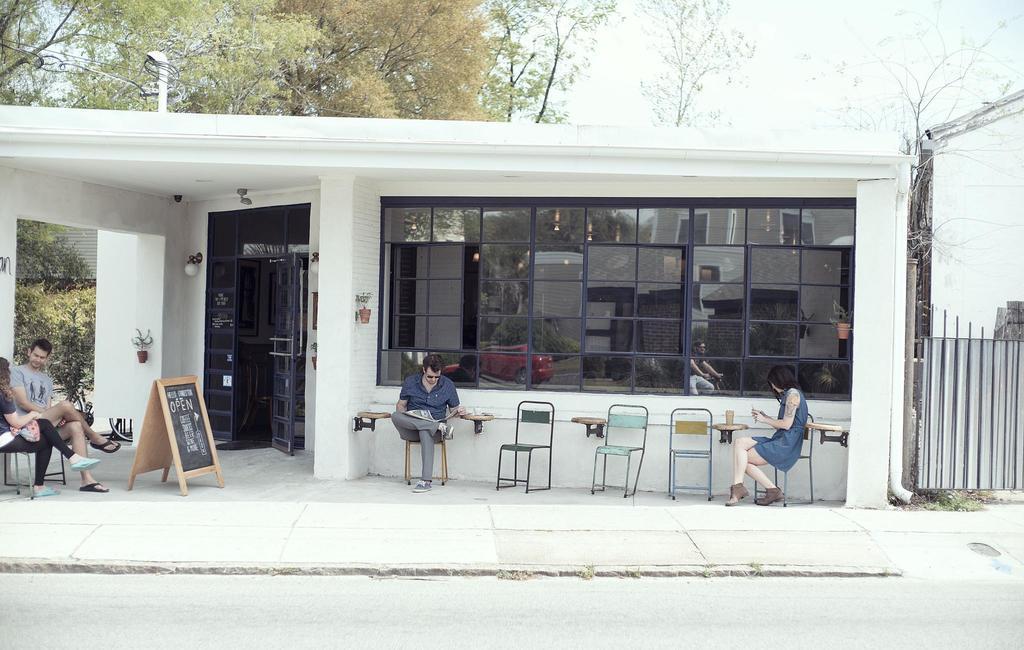How would you summarize this image in a sentence or two? It is a cafe and outside the cafe there are four people sitting on the chairs and there is is a board kept in front of the door of the cafe and in the background there are some trees. 